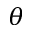<formula> <loc_0><loc_0><loc_500><loc_500>\theta</formula> 